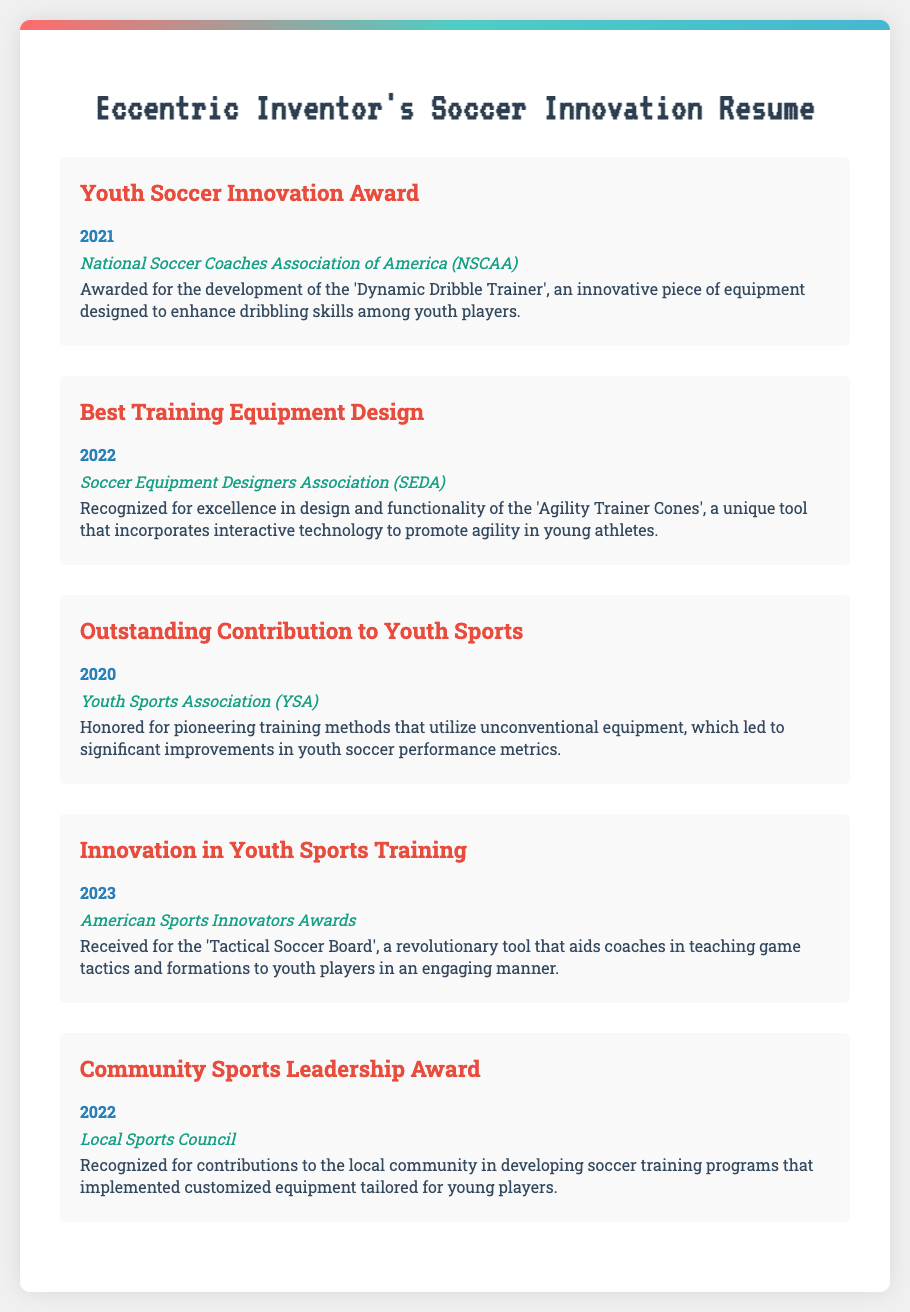what award was received in 2021? The award received in 2021 was the 'Youth Soccer Innovation Award' for the 'Dynamic Dribble Trainer'.
Answer: Youth Soccer Innovation Award who awarded the Best Training Equipment Design in 2022? The organization that awarded the Best Training Equipment Design in 2022 was the Soccer Equipment Designers Association.
Answer: Soccer Equipment Designers Association what innovative tool was recognized in 2023? The innovative tool recognized in 2023 was the 'Tactical Soccer Board'.
Answer: Tactical Soccer Board which award was given for contributions to community sports? The award given for contributions to community sports was the 'Community Sports Leadership Award'.
Answer: Community Sports Leadership Award in what year was the Outstanding Contribution to Youth Sports recognized? The Outstanding Contribution to Youth Sports was recognized in the year 2020.
Answer: 2020 how many awards are listed in the document? The document lists a total of five awards.
Answer: five which organization recognized pioneering training methods in 2020? The organization that recognized pioneering training methods in 2020 was the Youth Sports Association.
Answer: Youth Sports Association 